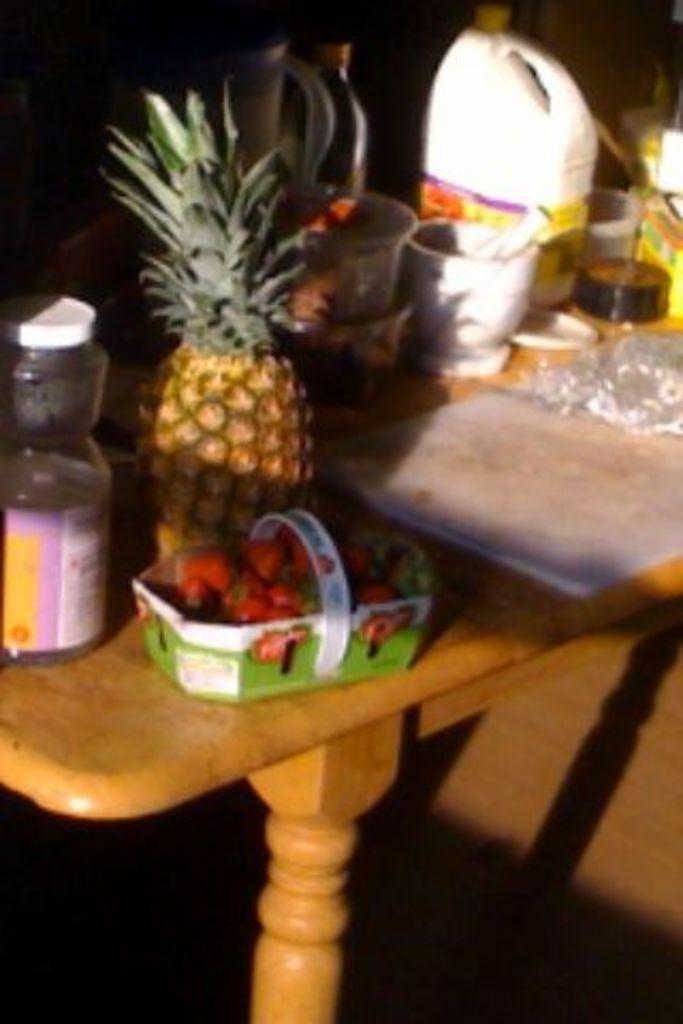Can you describe this image briefly? In the foreground of this image, on the table, there is a jar, pineapple, strawberries in a basket, bottle, can and few objects on it. 